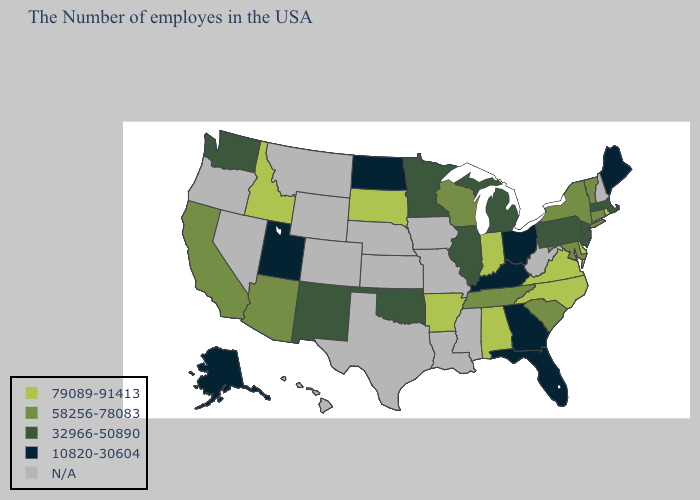What is the value of Oregon?
Give a very brief answer. N/A. Does the map have missing data?
Short answer required. Yes. What is the highest value in states that border Georgia?
Answer briefly. 79089-91413. What is the value of Florida?
Concise answer only. 10820-30604. Does the map have missing data?
Keep it brief. Yes. What is the value of South Dakota?
Write a very short answer. 79089-91413. Name the states that have a value in the range 79089-91413?
Keep it brief. Rhode Island, Delaware, Virginia, North Carolina, Indiana, Alabama, Arkansas, South Dakota, Idaho. Which states have the lowest value in the USA?
Concise answer only. Maine, Ohio, Florida, Georgia, Kentucky, North Dakota, Utah, Alaska. Does Idaho have the lowest value in the USA?
Answer briefly. No. What is the lowest value in the Northeast?
Short answer required. 10820-30604. Is the legend a continuous bar?
Write a very short answer. No. Which states have the lowest value in the USA?
Short answer required. Maine, Ohio, Florida, Georgia, Kentucky, North Dakota, Utah, Alaska. Among the states that border Idaho , does Washington have the lowest value?
Be succinct. No. Does Kentucky have the highest value in the South?
Short answer required. No. Which states have the lowest value in the USA?
Answer briefly. Maine, Ohio, Florida, Georgia, Kentucky, North Dakota, Utah, Alaska. 